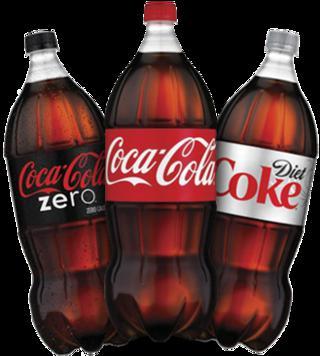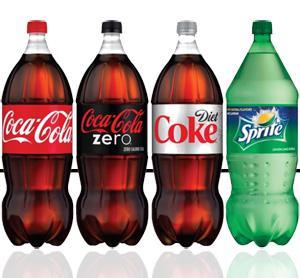The first image is the image on the left, the second image is the image on the right. For the images shown, is this caption "There are at most six bottles in the image pair." true? Answer yes or no. No. The first image is the image on the left, the second image is the image on the right. Assess this claim about the two images: "There are an odd number of sodas.". Correct or not? Answer yes or no. Yes. 